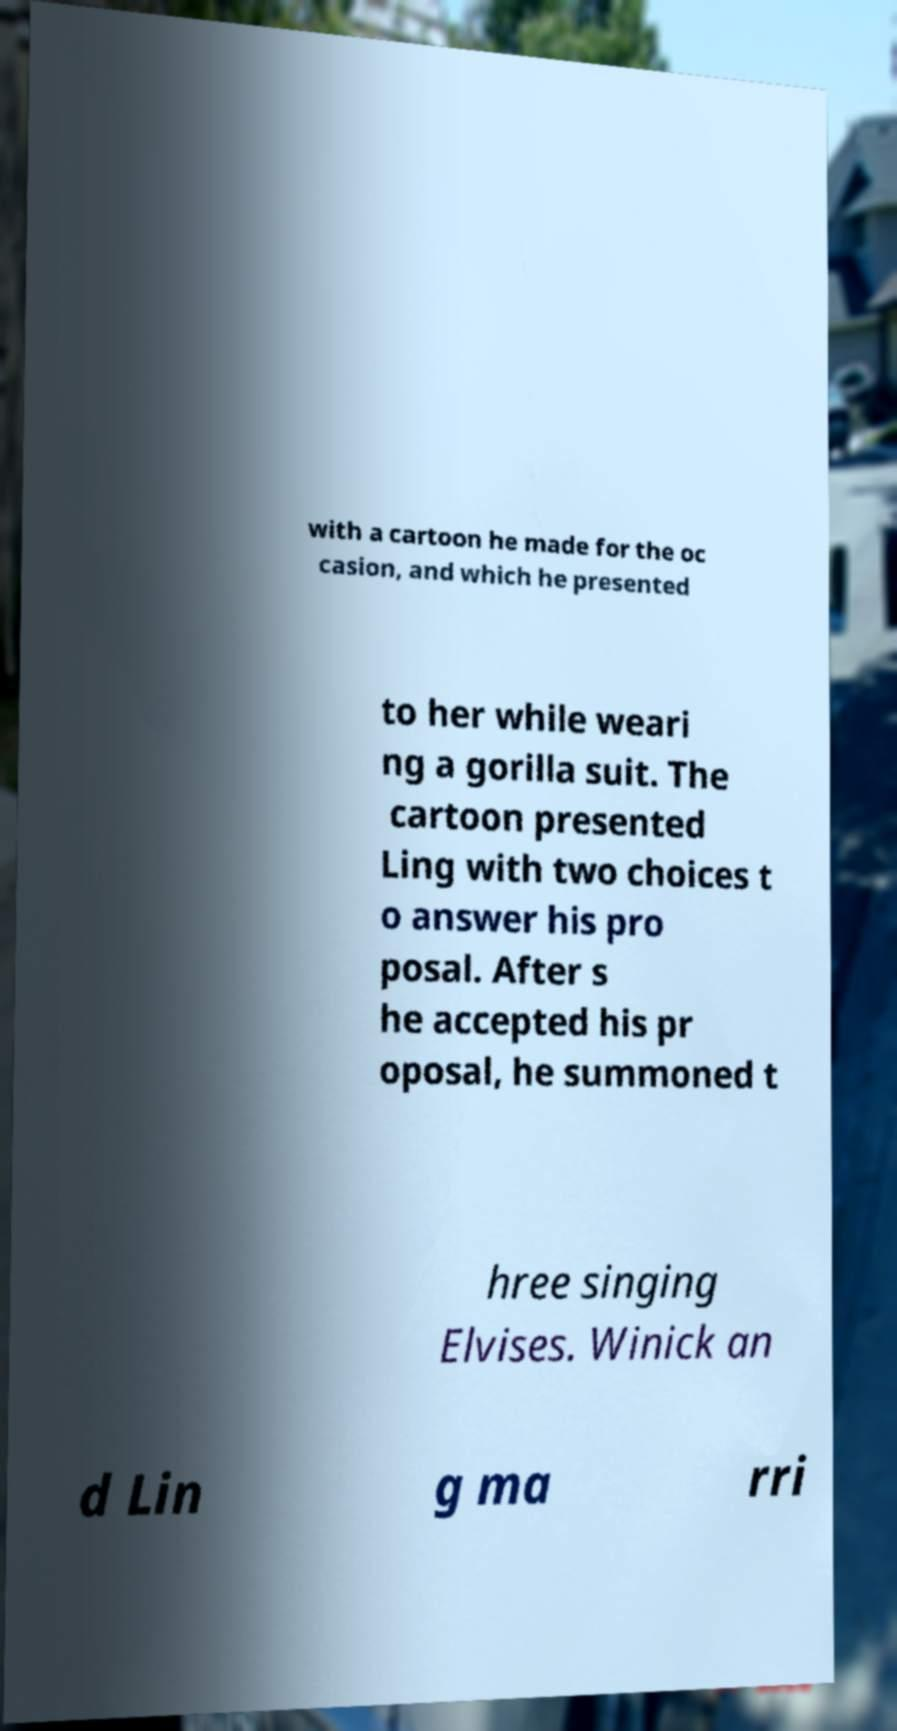What messages or text are displayed in this image? I need them in a readable, typed format. with a cartoon he made for the oc casion, and which he presented to her while weari ng a gorilla suit. The cartoon presented Ling with two choices t o answer his pro posal. After s he accepted his pr oposal, he summoned t hree singing Elvises. Winick an d Lin g ma rri 